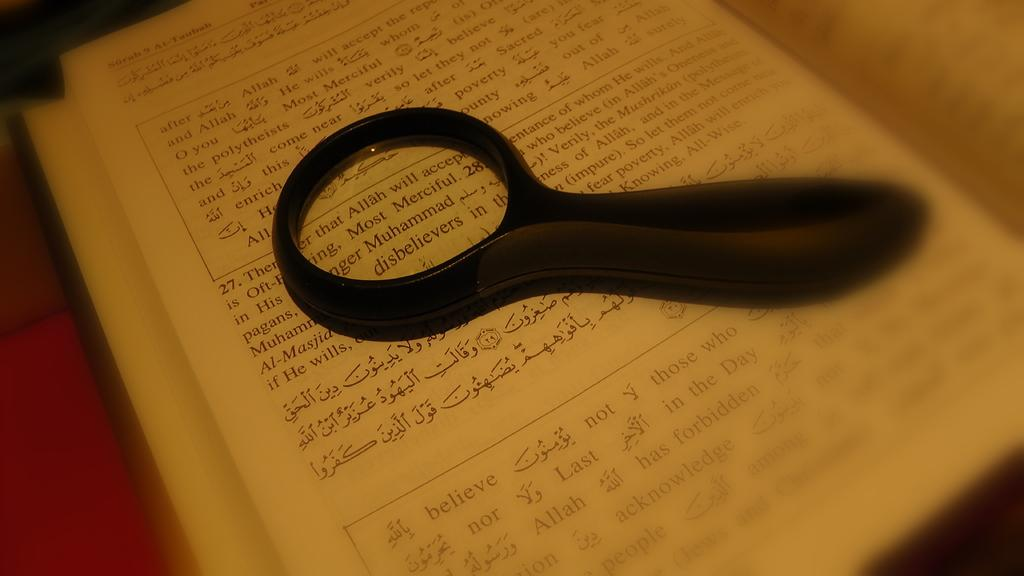<image>
Offer a succinct explanation of the picture presented. A magnifying glass sits on top of a book hovering over the name Muhammad 